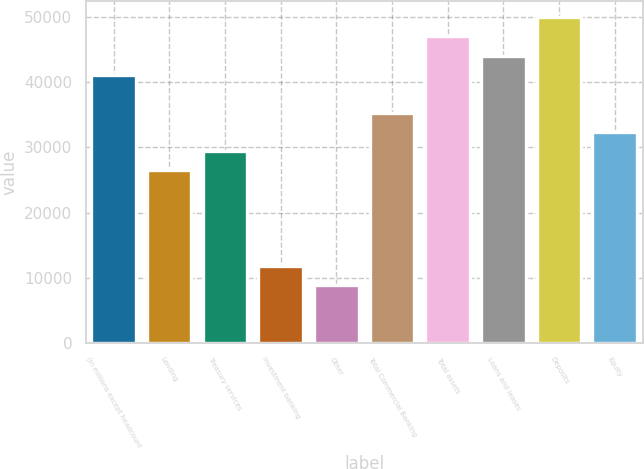Convert chart. <chart><loc_0><loc_0><loc_500><loc_500><bar_chart><fcel>(in millions except headcount<fcel>Lending<fcel>Treasury services<fcel>Investment banking<fcel>Other<fcel>Total Commercial Banking<fcel>Total assets<fcel>Loans and leases<fcel>Deposits<fcel>Equity<nl><fcel>41163.9<fcel>26462.8<fcel>29403<fcel>11761.7<fcel>8821.44<fcel>35283.4<fcel>47044.3<fcel>44104.1<fcel>49984.5<fcel>32343.2<nl></chart> 